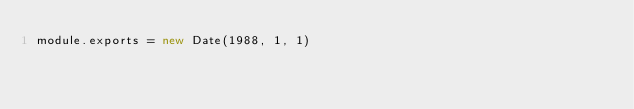<code> <loc_0><loc_0><loc_500><loc_500><_JavaScript_>module.exports = new Date(1988, 1, 1)
</code> 